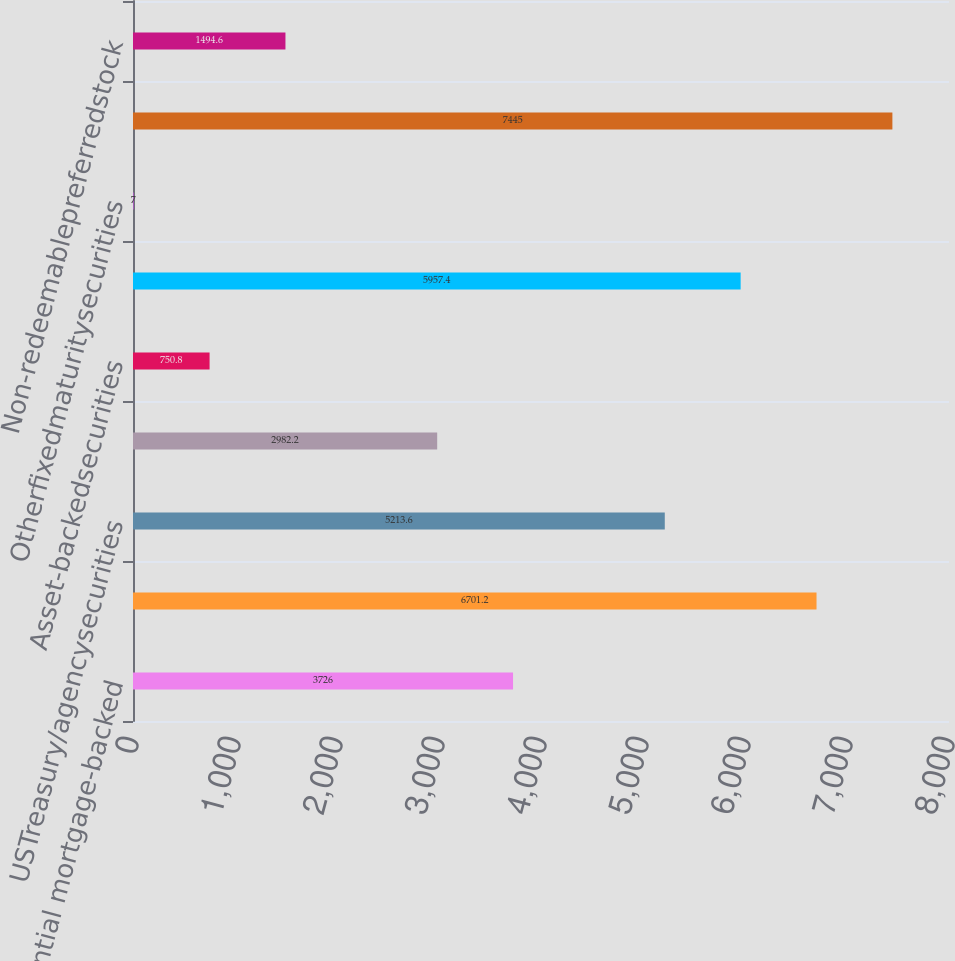<chart> <loc_0><loc_0><loc_500><loc_500><bar_chart><fcel>Residential mortgage-backed<fcel>Foreigncorporatesecurities<fcel>USTreasury/agencysecurities<fcel>Unnamed: 3<fcel>Asset-backedsecurities<fcel>Foreigngovernmentsecurities<fcel>Otherfixedmaturitysecurities<fcel>Total fixed maturity<fcel>Non-redeemablepreferredstock<nl><fcel>3726<fcel>6701.2<fcel>5213.6<fcel>2982.2<fcel>750.8<fcel>5957.4<fcel>7<fcel>7445<fcel>1494.6<nl></chart> 